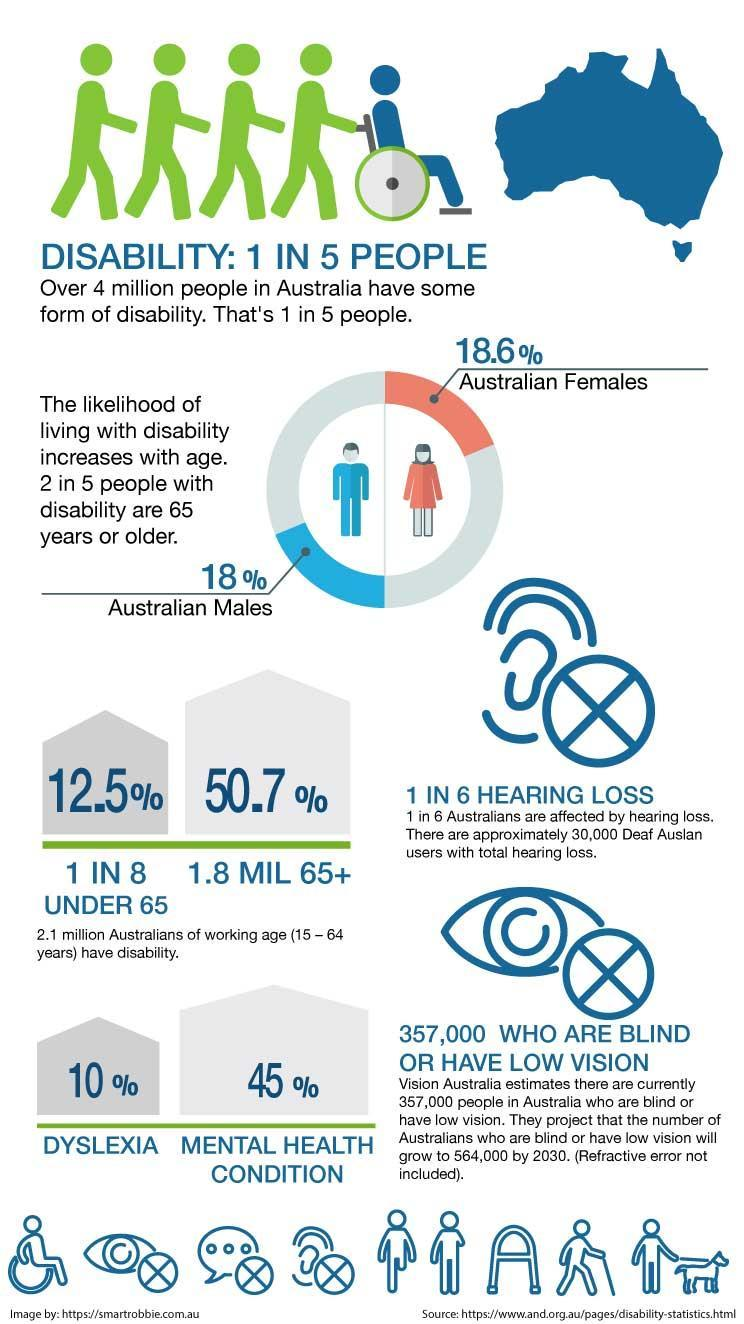What is the mental health condition percentage of Australians?
Answer the question with a short phrase. 45% Out of six how many Australians are not affected with hearing loss? 5 Which category posses more percent of disability, male or female? Female For Australians percentage of Dyslexia or Mental health condition is more? Mental health condition How many people are not disabled in Australia considering five people? 4 What is the percentage of DYSLEXIA for Australians? 10% What is the chance of disability for senior citizens? 2 in 5 people 